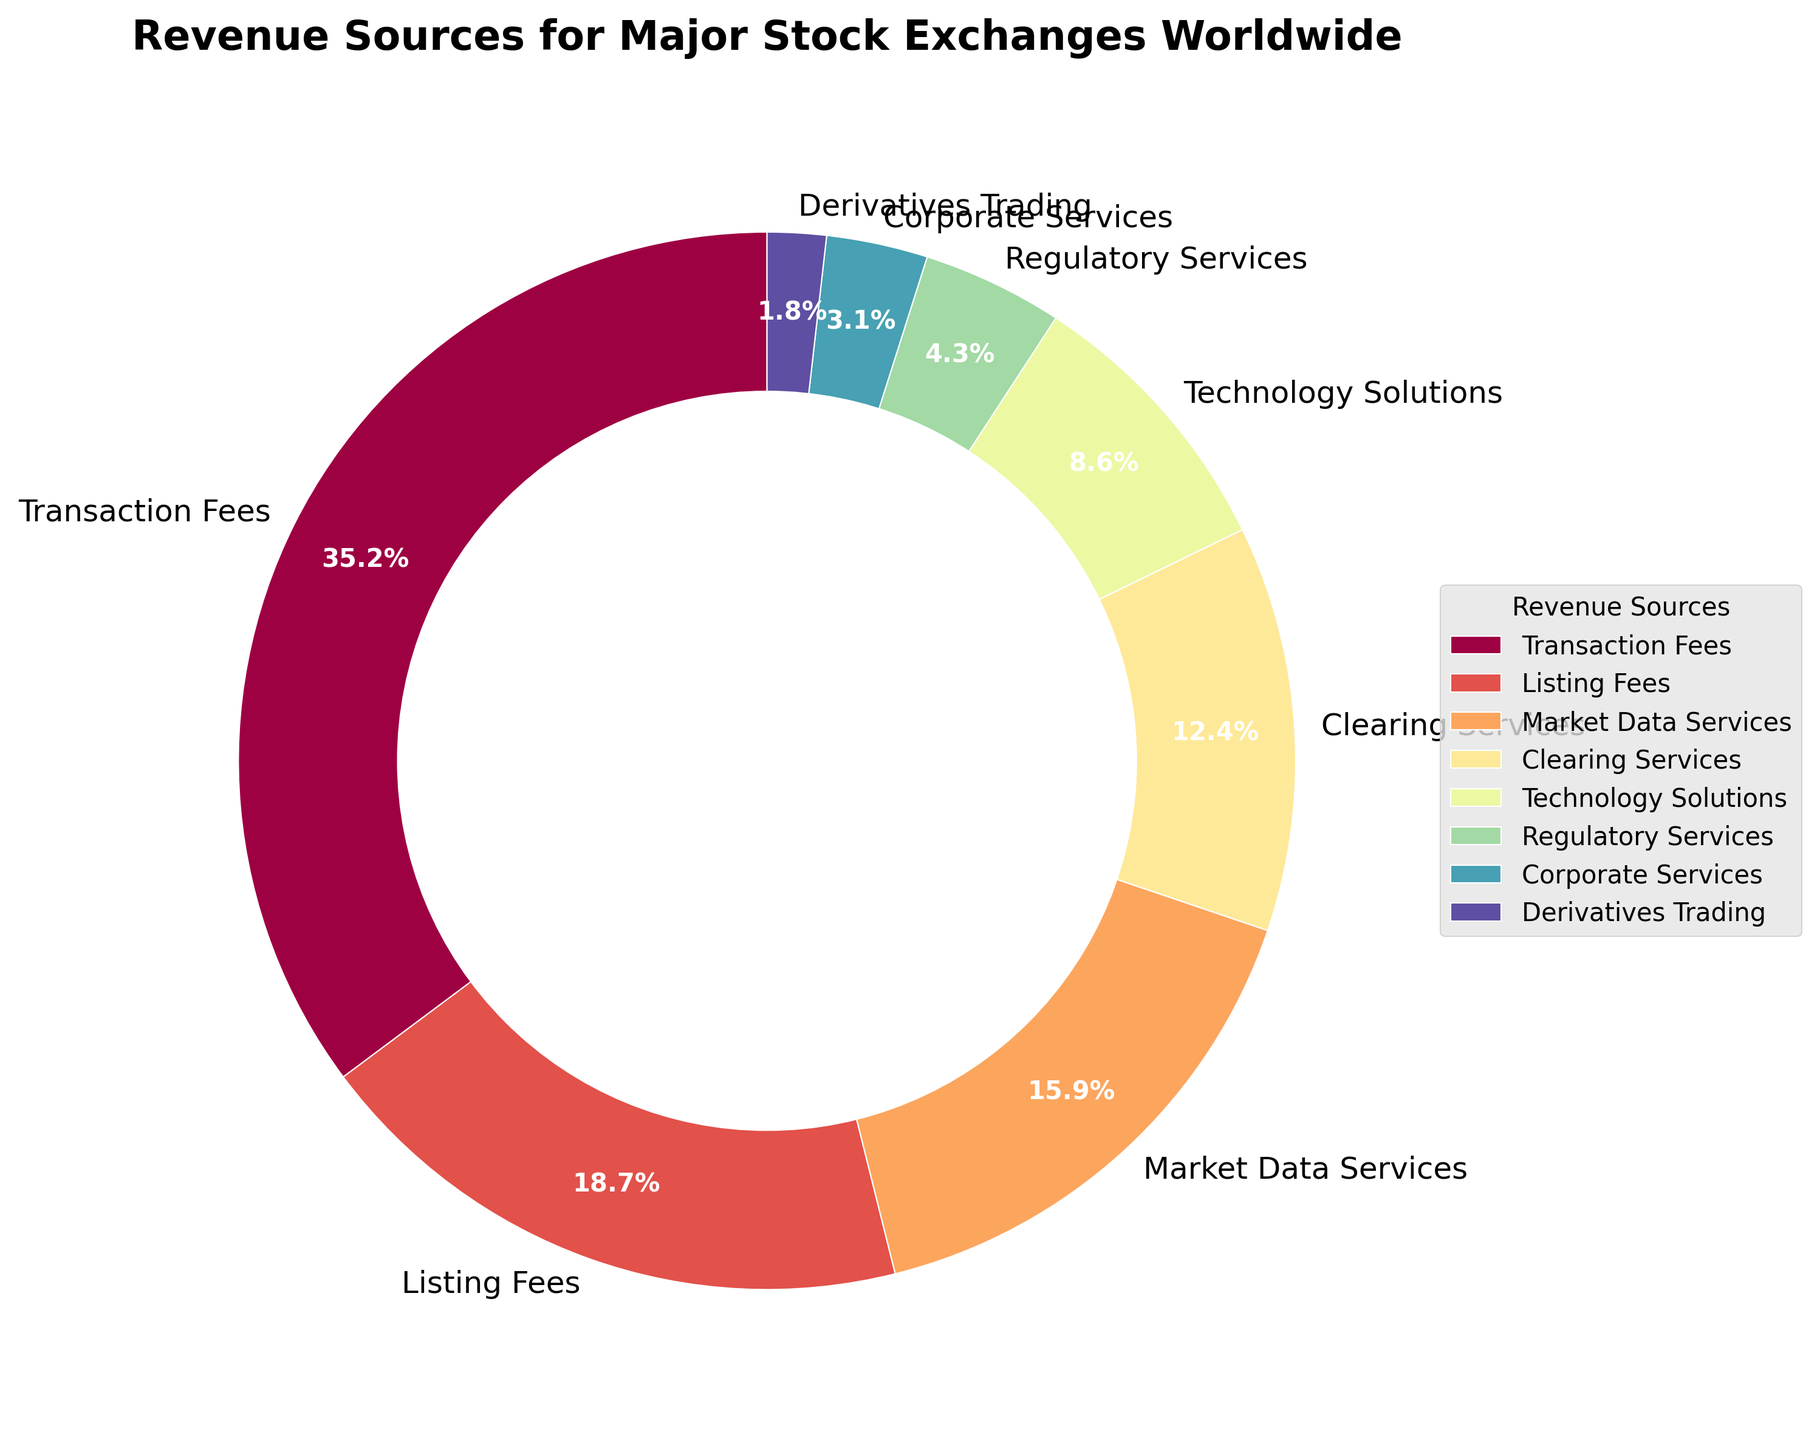What is the largest revenue source for major stock exchanges worldwide? The pie chart shows different revenue sources as slices, with the size of each slice proportional to its percentage. The slice labeled "Transaction Fees" is the largest.
Answer: Transaction Fees Which revenue source contributes the smallest percentage? By looking at the sizes of the slices in the pie chart, the smallest slice is labeled "Derivatives Trading."
Answer: Derivatives Trading How much more percentage do Transaction Fees contribute compared to Listing Fees? Transaction Fees contribute 35.2%, and Listing Fees contribute 18.7%. The difference is calculated as 35.2 - 18.7 = 16.5.
Answer: 16.5% What is the combined percentage of regulatory and corporate services? The percentage for Regulatory Services is 4.3%, and for Corporate Services, it is 3.1%. Summing these gives 4.3 + 3.1 = 7.4.
Answer: 7.4% Identify the revenue sources contributing more than 10%. By inspecting the chart, we see that Transaction Fees (35.2%), Listing Fees (18.7%), Market Data Services (15.9%), and Clearing Services (12.4%) are the slices larger than 10%.
Answer: Transaction Fees, Listing Fees, Market Data Services, Clearing Services Which two revenue sources have the closest percentages, and what are those percentages? Examining the pie chart, Technology Solutions (8.6%) and Regulatory Services (4.3%) are the nearest to each other in terms of visual size.
Answer: Technology Solutions and Regulatory Services By what factor is Transaction Fees larger than Derivatives Trading? Transaction Fees are 35.2%, and Derivatives Trading is 1.8%. The factor is calculated as 35.2 / 1.8 ≈ 19.56.
Answer: Approximately 19.56 What is the visual color of Market Data Services' slice in the pie chart? The pie chart uses a spectrum of colors. The slice for Market Data Services is visually assigned a specific color that typically might be a variant of purple based on the default colormap used.
Answer: Purple (likely) What percentage of the chart is not accounted for by the two highest revenue sources? The two highest sources are Transaction Fees (35.2%) and Listing Fees (18.7%), which together make 35.2 + 18.7 = 53.9%. The remaining percentage is 100 - 53.9 = 46.1%.
Answer: 46.1% 